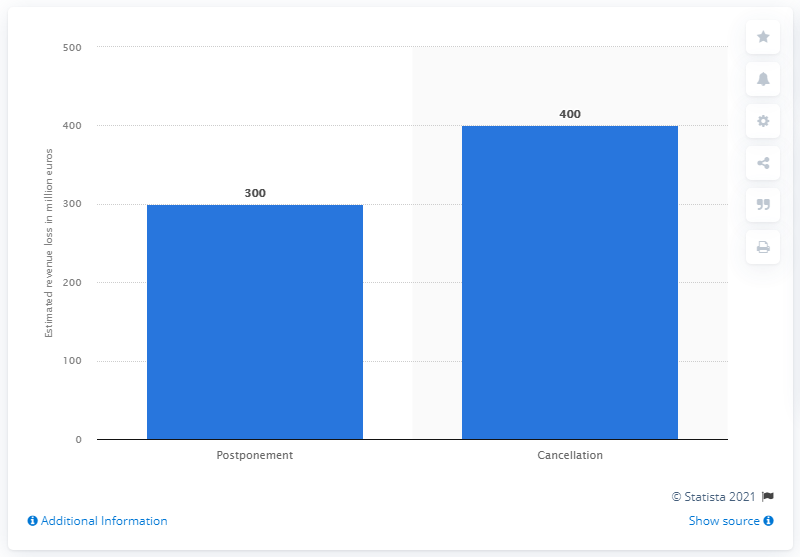Point out several critical features in this image. The cost of canceling the 2020 European Football Championship for UEFA was reported to be 400.. The postponement of the 2020 European Football Championship cost UEFA approximately 300 million euros. 